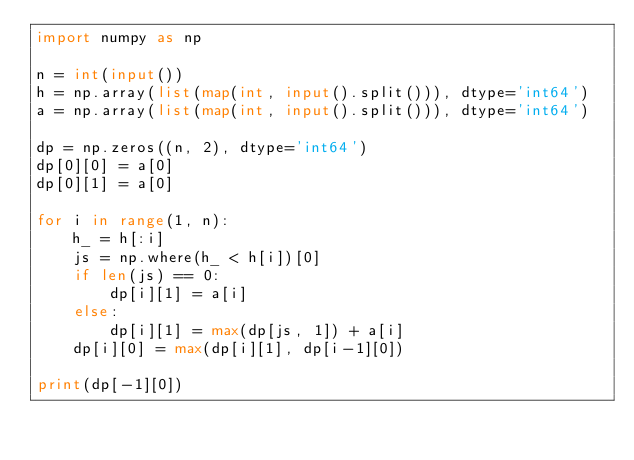Convert code to text. <code><loc_0><loc_0><loc_500><loc_500><_Python_>import numpy as np

n = int(input())
h = np.array(list(map(int, input().split())), dtype='int64')
a = np.array(list(map(int, input().split())), dtype='int64')

dp = np.zeros((n, 2), dtype='int64')
dp[0][0] = a[0]
dp[0][1] = a[0]

for i in range(1, n):
    h_ = h[:i]
    js = np.where(h_ < h[i])[0]
    if len(js) == 0:
        dp[i][1] = a[i]
    else:
        dp[i][1] = max(dp[js, 1]) + a[i]
    dp[i][0] = max(dp[i][1], dp[i-1][0])

print(dp[-1][0])
</code> 